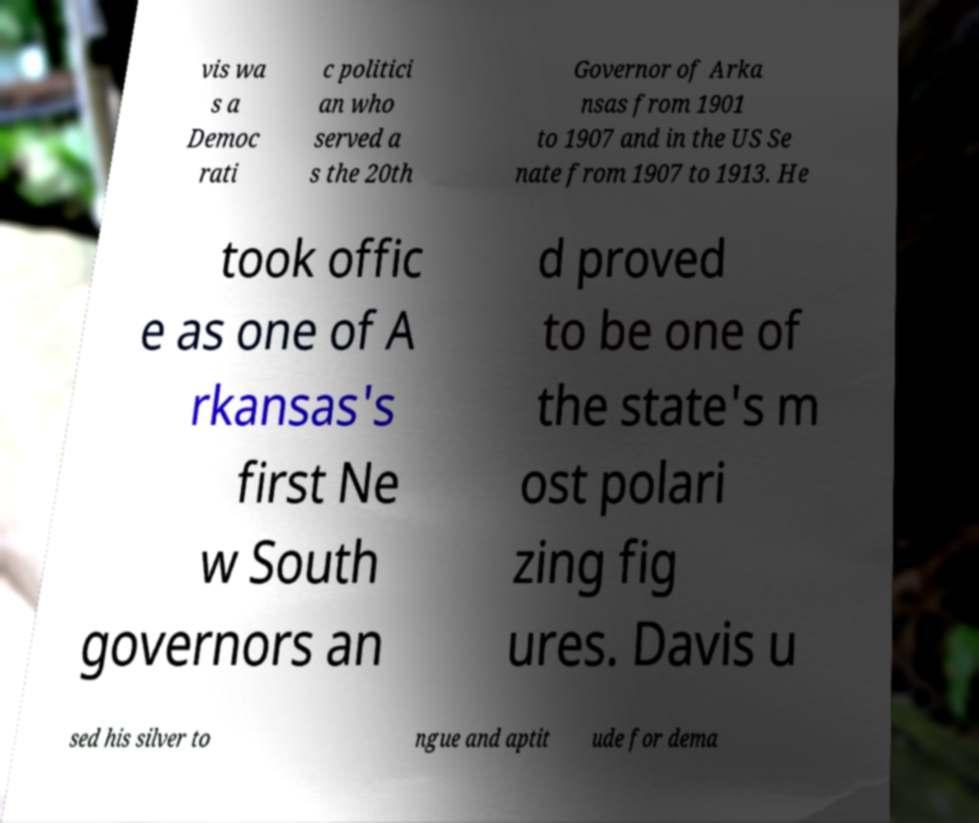Please identify and transcribe the text found in this image. vis wa s a Democ rati c politici an who served a s the 20th Governor of Arka nsas from 1901 to 1907 and in the US Se nate from 1907 to 1913. He took offic e as one of A rkansas's first Ne w South governors an d proved to be one of the state's m ost polari zing fig ures. Davis u sed his silver to ngue and aptit ude for dema 